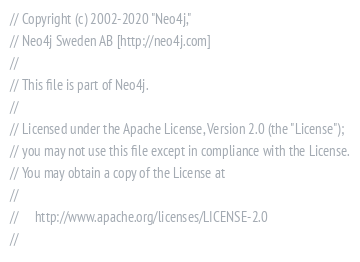<code> <loc_0><loc_0><loc_500><loc_500><_C#_>// Copyright (c) 2002-2020 "Neo4j,"
// Neo4j Sweden AB [http://neo4j.com]
// 
// This file is part of Neo4j.
// 
// Licensed under the Apache License, Version 2.0 (the "License");
// you may not use this file except in compliance with the License.
// You may obtain a copy of the License at
// 
//     http://www.apache.org/licenses/LICENSE-2.0
// </code> 